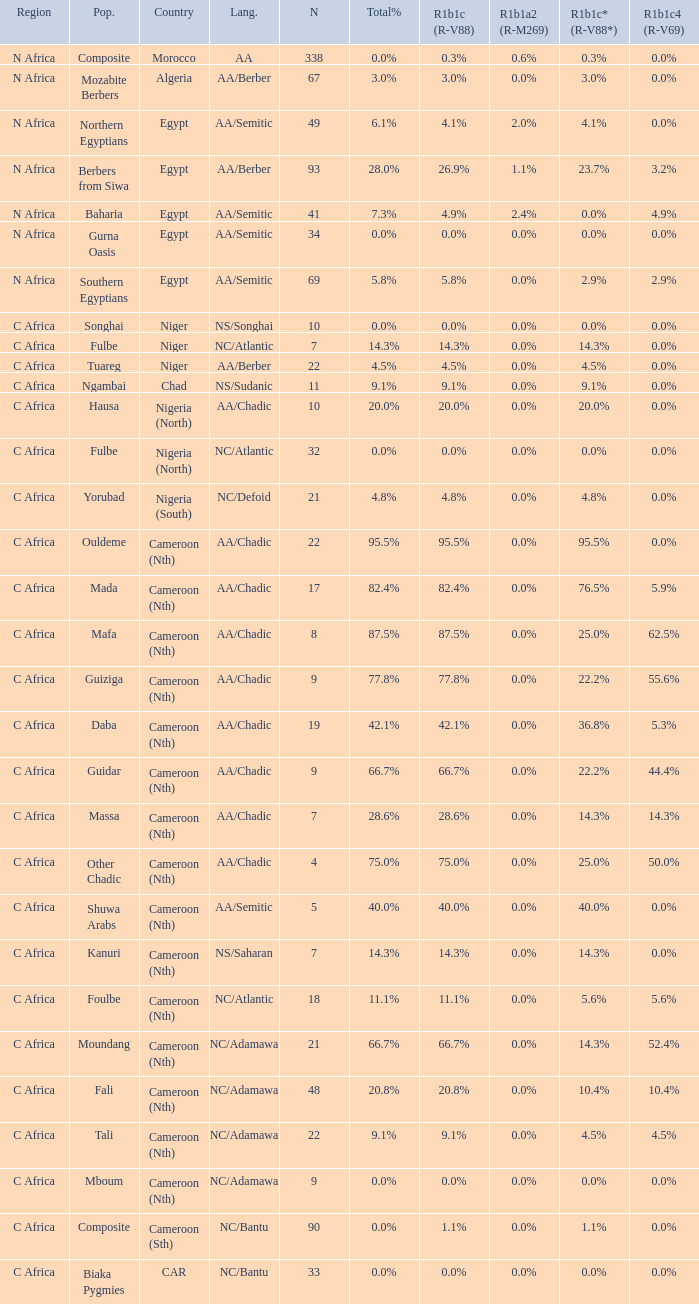What languages are spoken in Niger with r1b1c (r-v88) of 0.0%? NS/Songhai. 